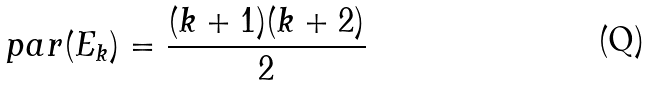Convert formula to latex. <formula><loc_0><loc_0><loc_500><loc_500>p a r ( E _ { k } ) = \frac { ( k + 1 ) ( k + 2 ) } { 2 }</formula> 